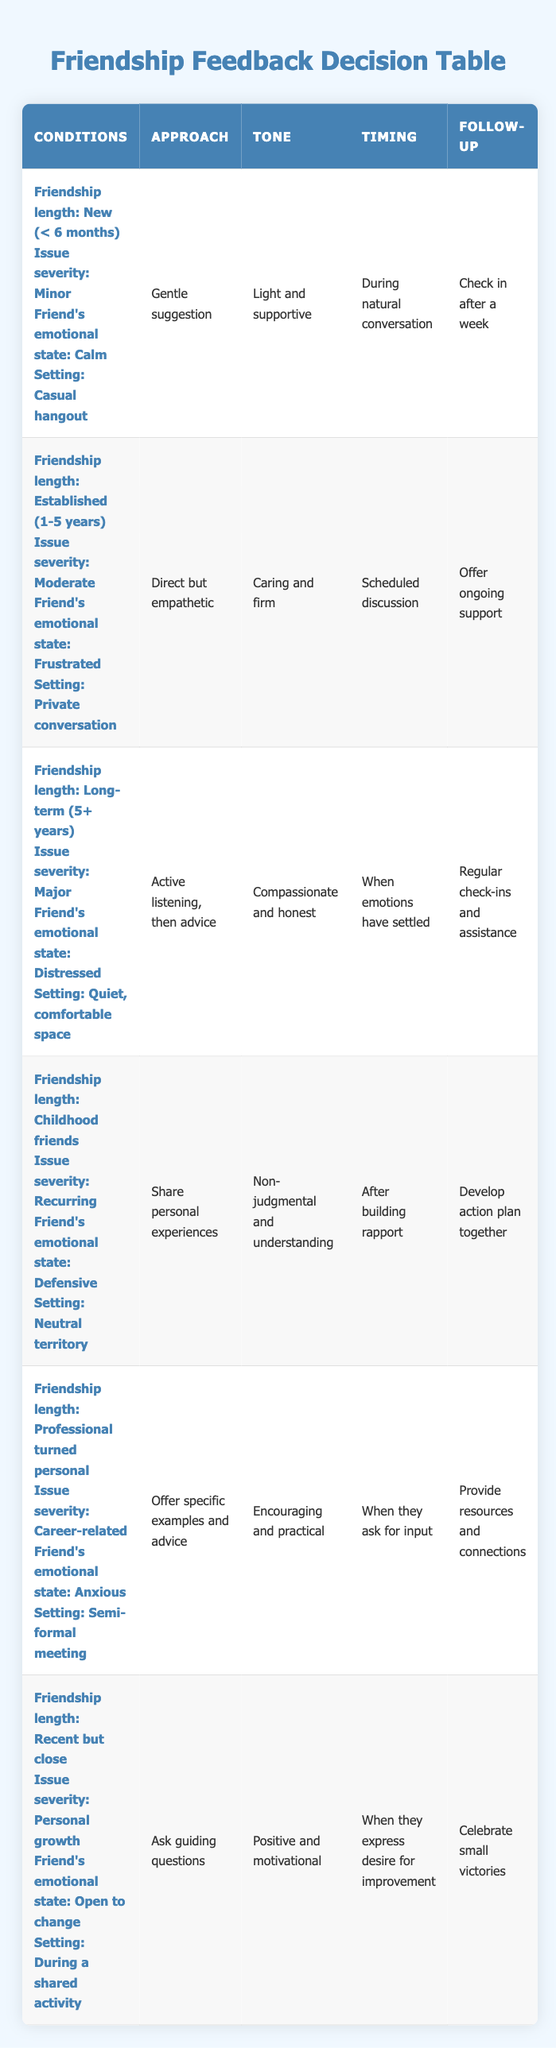What approach should be taken when providing feedback to a new friend regarding a minor issue while they are calm? According to the table, when providing feedback to a new friend with a minor issue and their emotional state is calm, the approach should be a "Gentle suggestion."
Answer: Gentle suggestion Which tone is suggested when addressing a friend's major issue in a long-term friendship? The table indicates that when dealing with a major issue in a long-term friendship, the tone should be "Compassionate and honest."
Answer: Compassionate and honest Is the follow-up action the same for an established friendship with a moderate issue and a long-term friendship with a major issue? The follow-up for an established friendship with a moderate issue is to "Offer ongoing support," while the follow-up for a long-term friendship with a major issue is to "Regular check-ins and assistance." Since these follow-ups are different, the answer is no.
Answer: No What is the emotional state of a friend when addressing a career-related issue in a professional turned personal friendship? By examining the table, it is identified that the friend's emotional state should be "Anxious" when addressing a career-related issue in a professional turned personal friendship.
Answer: Anxious How many unique approaches are mentioned in the table? The table lists six unique approaches: "Gentle suggestion," "Direct but empathetic," "Active listening, then advice," "Share personal experiences," "Offer specific examples and advice," and "Ask guiding questions." Counting them gives a total of six approaches.
Answer: 6 What tone should be used when giving feedback to childhood friends who feel defensive? According to the data in the table, the tone that should be used when giving feedback to childhood friends who feel defensive is "Non-judgmental and understanding."
Answer: Non-judgmental and understanding What is the difference in settings for providing feedback to a new friend versus a long-term friend? The new friend's feedback should occur in a "Casual hangout," while the long-term friend's feedback should take place in a "Quiet, comfortable space." Therefore, the setting differs in both formality and comfort.
Answer: Casual hangout vs. Quiet, comfortable space When should feedback be given to a recent but close friendship regarding personal growth? The table states that feedback should be given during a shared activity, specifically "When they express desire for improvement," emphasizing the importance of timing aligned with the friend's openness to change.
Answer: During a shared activity What are the follow-up actions recommended for each type of feedback scenario listed? The follow-up actions vary: for a new friend, it is to "Check in after a week"; for an established friend, it's "Offer ongoing support"; for a long-term friend, it's "Regular check-ins and assistance"; for childhood friends, it's "Develop action plan together"; for professional friends, it's "Provide resources and connections"; and for recent close friends, it's "Celebrate small victories."
Answer: Various follow-up actions for each scenario 